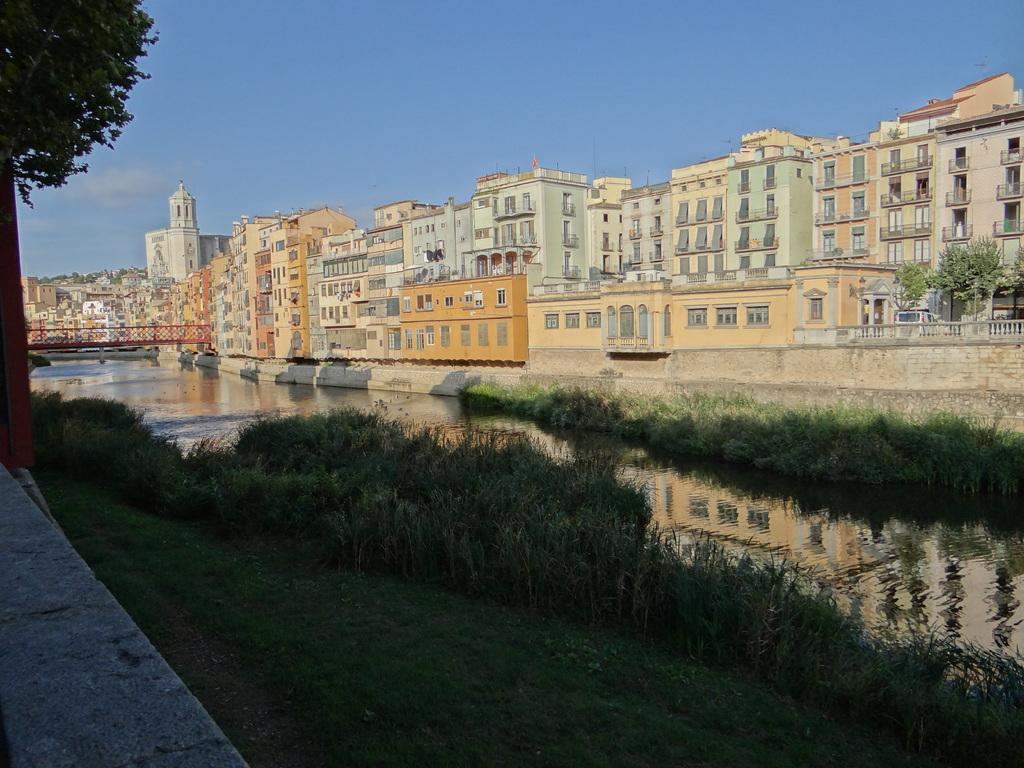Can you describe this image briefly? In this picture we can see the buildings. In front of the buildings, there are trees, a bridge, water and grass. At the top of the image, there is the sky. 